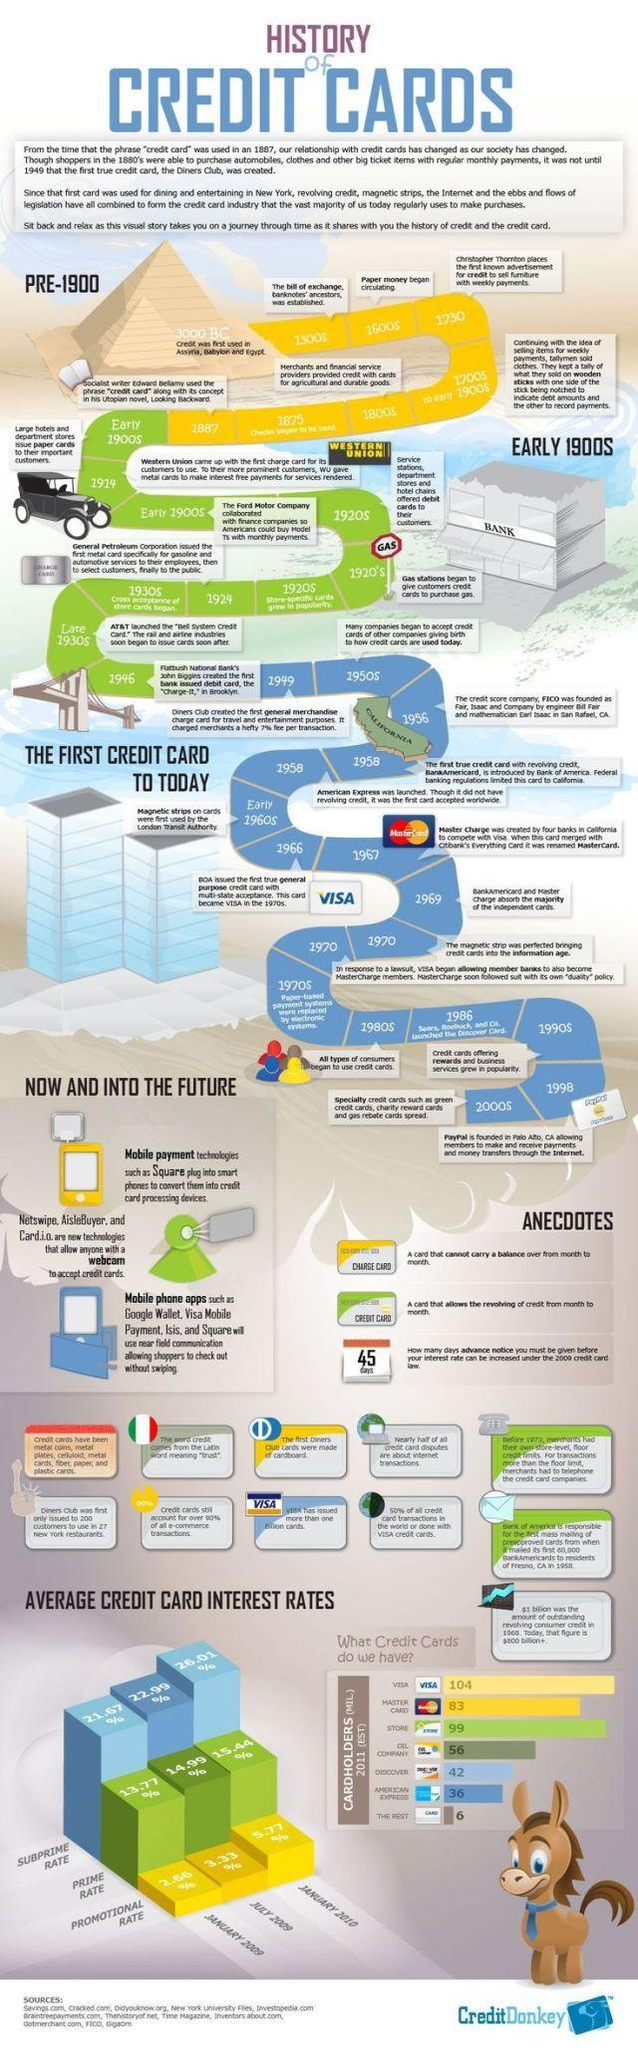Outline some significant characteristics in this image. In July 2009, the subprime rate of credit card was 22.99%. In January 2009, the prime rate for credit cards was 13.77%. As of January 2010, the promotional rate for credit cards was 5.77%. The most commonly used credit card is VISA. 